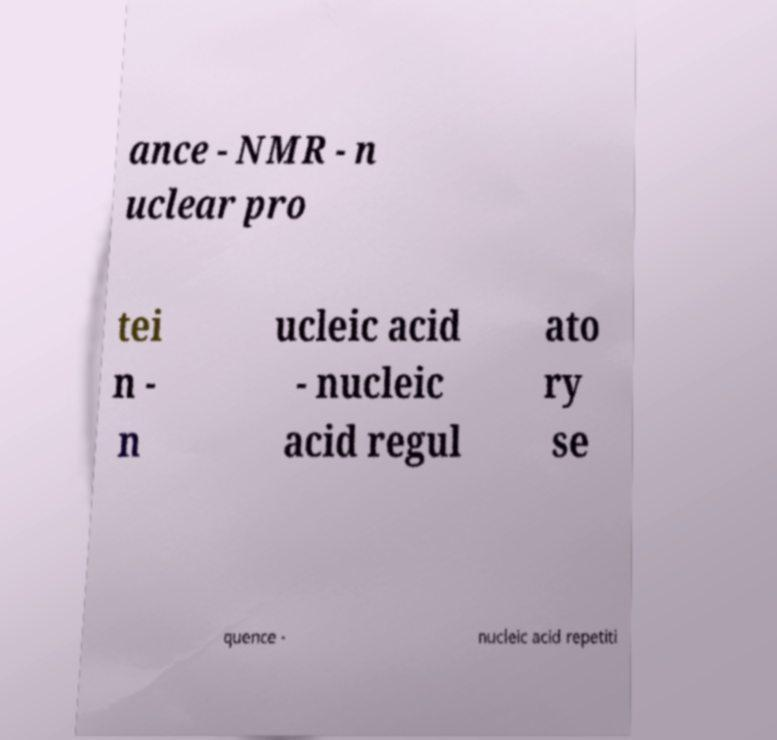I need the written content from this picture converted into text. Can you do that? ance - NMR - n uclear pro tei n - n ucleic acid - nucleic acid regul ato ry se quence - nucleic acid repetiti 